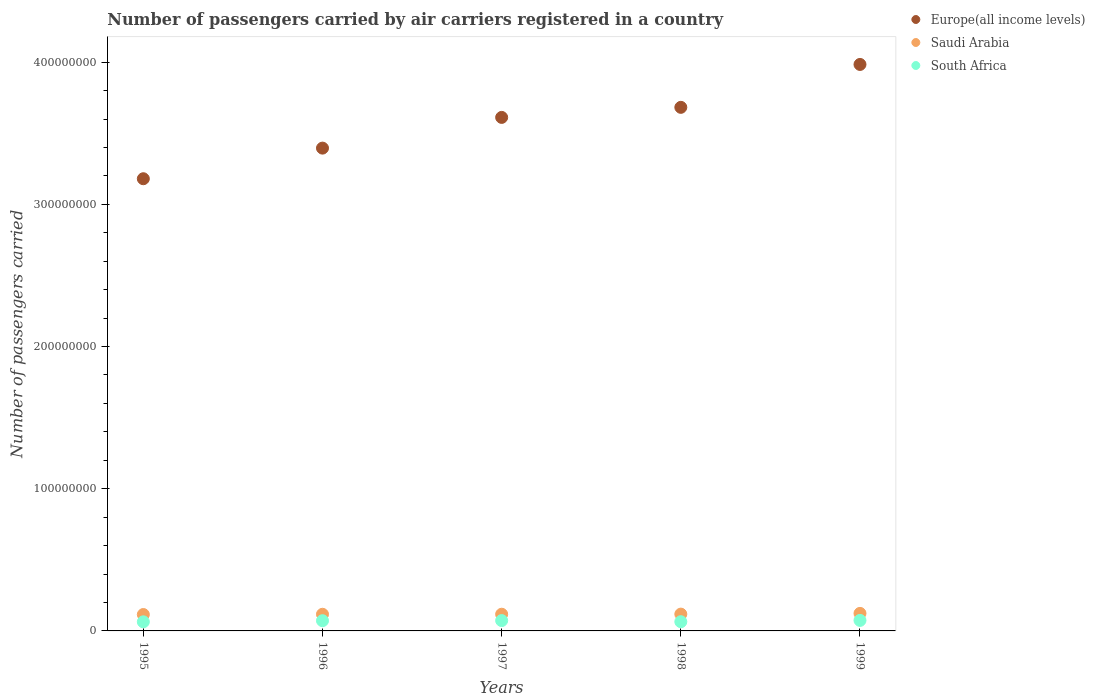What is the number of passengers carried by air carriers in Saudi Arabia in 1995?
Ensure brevity in your answer.  1.15e+07. Across all years, what is the maximum number of passengers carried by air carriers in Saudi Arabia?
Give a very brief answer. 1.23e+07. Across all years, what is the minimum number of passengers carried by air carriers in South Africa?
Your answer should be very brief. 6.40e+06. In which year was the number of passengers carried by air carriers in Saudi Arabia maximum?
Your response must be concise. 1999. What is the total number of passengers carried by air carriers in Saudi Arabia in the graph?
Provide a short and direct response. 5.91e+07. What is the difference between the number of passengers carried by air carriers in Saudi Arabia in 1995 and that in 1999?
Make the answer very short. -8.04e+05. What is the difference between the number of passengers carried by air carriers in Saudi Arabia in 1998 and the number of passengers carried by air carriers in South Africa in 1996?
Ensure brevity in your answer.  4.63e+06. What is the average number of passengers carried by air carriers in South Africa per year?
Keep it short and to the point. 6.95e+06. In the year 1998, what is the difference between the number of passengers carried by air carriers in Europe(all income levels) and number of passengers carried by air carriers in Saudi Arabia?
Provide a succinct answer. 3.56e+08. What is the ratio of the number of passengers carried by air carriers in Saudi Arabia in 1996 to that in 1999?
Provide a succinct answer. 0.95. Is the number of passengers carried by air carriers in South Africa in 1996 less than that in 1998?
Offer a terse response. No. Is the difference between the number of passengers carried by air carriers in Europe(all income levels) in 1995 and 1999 greater than the difference between the number of passengers carried by air carriers in Saudi Arabia in 1995 and 1999?
Offer a terse response. No. What is the difference between the highest and the second highest number of passengers carried by air carriers in South Africa?
Your answer should be compact. 1.30e+05. What is the difference between the highest and the lowest number of passengers carried by air carriers in Saudi Arabia?
Offer a terse response. 8.04e+05. In how many years, is the number of passengers carried by air carriers in Saudi Arabia greater than the average number of passengers carried by air carriers in Saudi Arabia taken over all years?
Provide a short and direct response. 1. Does the number of passengers carried by air carriers in Europe(all income levels) monotonically increase over the years?
Provide a succinct answer. Yes. Is the number of passengers carried by air carriers in Saudi Arabia strictly greater than the number of passengers carried by air carriers in Europe(all income levels) over the years?
Provide a succinct answer. No. Is the number of passengers carried by air carriers in Saudi Arabia strictly less than the number of passengers carried by air carriers in Europe(all income levels) over the years?
Keep it short and to the point. Yes. How many years are there in the graph?
Your response must be concise. 5. What is the difference between two consecutive major ticks on the Y-axis?
Your answer should be very brief. 1.00e+08. Are the values on the major ticks of Y-axis written in scientific E-notation?
Offer a very short reply. No. Does the graph contain any zero values?
Keep it short and to the point. No. Does the graph contain grids?
Provide a short and direct response. No. Where does the legend appear in the graph?
Your response must be concise. Top right. How many legend labels are there?
Your answer should be very brief. 3. How are the legend labels stacked?
Provide a short and direct response. Vertical. What is the title of the graph?
Your response must be concise. Number of passengers carried by air carriers registered in a country. Does "Greece" appear as one of the legend labels in the graph?
Your answer should be compact. No. What is the label or title of the Y-axis?
Offer a terse response. Number of passengers carried. What is the Number of passengers carried in Europe(all income levels) in 1995?
Keep it short and to the point. 3.18e+08. What is the Number of passengers carried in Saudi Arabia in 1995?
Offer a terse response. 1.15e+07. What is the Number of passengers carried of South Africa in 1995?
Give a very brief answer. 6.40e+06. What is the Number of passengers carried in Europe(all income levels) in 1996?
Provide a short and direct response. 3.40e+08. What is the Number of passengers carried of Saudi Arabia in 1996?
Provide a short and direct response. 1.17e+07. What is the Number of passengers carried in South Africa in 1996?
Your response must be concise. 7.18e+06. What is the Number of passengers carried of Europe(all income levels) in 1997?
Offer a very short reply. 3.61e+08. What is the Number of passengers carried of Saudi Arabia in 1997?
Give a very brief answer. 1.17e+07. What is the Number of passengers carried in South Africa in 1997?
Offer a terse response. 7.27e+06. What is the Number of passengers carried in Europe(all income levels) in 1998?
Your response must be concise. 3.68e+08. What is the Number of passengers carried of Saudi Arabia in 1998?
Offer a terse response. 1.18e+07. What is the Number of passengers carried in South Africa in 1998?
Provide a succinct answer. 6.48e+06. What is the Number of passengers carried in Europe(all income levels) in 1999?
Your answer should be compact. 3.98e+08. What is the Number of passengers carried of Saudi Arabia in 1999?
Your answer should be very brief. 1.23e+07. What is the Number of passengers carried in South Africa in 1999?
Offer a very short reply. 7.40e+06. Across all years, what is the maximum Number of passengers carried of Europe(all income levels)?
Ensure brevity in your answer.  3.98e+08. Across all years, what is the maximum Number of passengers carried of Saudi Arabia?
Make the answer very short. 1.23e+07. Across all years, what is the maximum Number of passengers carried of South Africa?
Your answer should be very brief. 7.40e+06. Across all years, what is the minimum Number of passengers carried of Europe(all income levels)?
Make the answer very short. 3.18e+08. Across all years, what is the minimum Number of passengers carried in Saudi Arabia?
Your response must be concise. 1.15e+07. Across all years, what is the minimum Number of passengers carried of South Africa?
Keep it short and to the point. 6.40e+06. What is the total Number of passengers carried in Europe(all income levels) in the graph?
Your answer should be very brief. 1.79e+09. What is the total Number of passengers carried in Saudi Arabia in the graph?
Make the answer very short. 5.91e+07. What is the total Number of passengers carried in South Africa in the graph?
Your answer should be very brief. 3.47e+07. What is the difference between the Number of passengers carried of Europe(all income levels) in 1995 and that in 1996?
Offer a terse response. -2.15e+07. What is the difference between the Number of passengers carried in Saudi Arabia in 1995 and that in 1996?
Ensure brevity in your answer.  -1.82e+05. What is the difference between the Number of passengers carried of South Africa in 1995 and that in 1996?
Keep it short and to the point. -7.88e+05. What is the difference between the Number of passengers carried in Europe(all income levels) in 1995 and that in 1997?
Give a very brief answer. -4.31e+07. What is the difference between the Number of passengers carried of Saudi Arabia in 1995 and that in 1997?
Provide a succinct answer. -2.14e+05. What is the difference between the Number of passengers carried in South Africa in 1995 and that in 1997?
Provide a succinct answer. -8.79e+05. What is the difference between the Number of passengers carried in Europe(all income levels) in 1995 and that in 1998?
Ensure brevity in your answer.  -5.02e+07. What is the difference between the Number of passengers carried in Saudi Arabia in 1995 and that in 1998?
Keep it short and to the point. -2.92e+05. What is the difference between the Number of passengers carried of South Africa in 1995 and that in 1998?
Your answer should be very brief. -8.40e+04. What is the difference between the Number of passengers carried in Europe(all income levels) in 1995 and that in 1999?
Keep it short and to the point. -8.04e+07. What is the difference between the Number of passengers carried of Saudi Arabia in 1995 and that in 1999?
Provide a succinct answer. -8.04e+05. What is the difference between the Number of passengers carried in South Africa in 1995 and that in 1999?
Provide a succinct answer. -1.01e+06. What is the difference between the Number of passengers carried of Europe(all income levels) in 1996 and that in 1997?
Your answer should be compact. -2.16e+07. What is the difference between the Number of passengers carried in Saudi Arabia in 1996 and that in 1997?
Provide a succinct answer. -3.19e+04. What is the difference between the Number of passengers carried of South Africa in 1996 and that in 1997?
Make the answer very short. -9.11e+04. What is the difference between the Number of passengers carried in Europe(all income levels) in 1996 and that in 1998?
Offer a very short reply. -2.87e+07. What is the difference between the Number of passengers carried in Saudi Arabia in 1996 and that in 1998?
Ensure brevity in your answer.  -1.10e+05. What is the difference between the Number of passengers carried of South Africa in 1996 and that in 1998?
Offer a terse response. 7.04e+05. What is the difference between the Number of passengers carried in Europe(all income levels) in 1996 and that in 1999?
Your answer should be very brief. -5.88e+07. What is the difference between the Number of passengers carried in Saudi Arabia in 1996 and that in 1999?
Make the answer very short. -6.22e+05. What is the difference between the Number of passengers carried in South Africa in 1996 and that in 1999?
Offer a very short reply. -2.21e+05. What is the difference between the Number of passengers carried of Europe(all income levels) in 1997 and that in 1998?
Keep it short and to the point. -7.08e+06. What is the difference between the Number of passengers carried of Saudi Arabia in 1997 and that in 1998?
Provide a short and direct response. -7.80e+04. What is the difference between the Number of passengers carried of South Africa in 1997 and that in 1998?
Your answer should be very brief. 7.95e+05. What is the difference between the Number of passengers carried of Europe(all income levels) in 1997 and that in 1999?
Your response must be concise. -3.72e+07. What is the difference between the Number of passengers carried in Saudi Arabia in 1997 and that in 1999?
Provide a succinct answer. -5.90e+05. What is the difference between the Number of passengers carried in South Africa in 1997 and that in 1999?
Your answer should be very brief. -1.30e+05. What is the difference between the Number of passengers carried of Europe(all income levels) in 1998 and that in 1999?
Offer a terse response. -3.02e+07. What is the difference between the Number of passengers carried of Saudi Arabia in 1998 and that in 1999?
Ensure brevity in your answer.  -5.12e+05. What is the difference between the Number of passengers carried in South Africa in 1998 and that in 1999?
Make the answer very short. -9.24e+05. What is the difference between the Number of passengers carried of Europe(all income levels) in 1995 and the Number of passengers carried of Saudi Arabia in 1996?
Ensure brevity in your answer.  3.06e+08. What is the difference between the Number of passengers carried in Europe(all income levels) in 1995 and the Number of passengers carried in South Africa in 1996?
Your response must be concise. 3.11e+08. What is the difference between the Number of passengers carried of Saudi Arabia in 1995 and the Number of passengers carried of South Africa in 1996?
Make the answer very short. 4.34e+06. What is the difference between the Number of passengers carried of Europe(all income levels) in 1995 and the Number of passengers carried of Saudi Arabia in 1997?
Provide a succinct answer. 3.06e+08. What is the difference between the Number of passengers carried of Europe(all income levels) in 1995 and the Number of passengers carried of South Africa in 1997?
Provide a short and direct response. 3.11e+08. What is the difference between the Number of passengers carried of Saudi Arabia in 1995 and the Number of passengers carried of South Africa in 1997?
Your answer should be compact. 4.25e+06. What is the difference between the Number of passengers carried in Europe(all income levels) in 1995 and the Number of passengers carried in Saudi Arabia in 1998?
Give a very brief answer. 3.06e+08. What is the difference between the Number of passengers carried in Europe(all income levels) in 1995 and the Number of passengers carried in South Africa in 1998?
Provide a succinct answer. 3.12e+08. What is the difference between the Number of passengers carried in Saudi Arabia in 1995 and the Number of passengers carried in South Africa in 1998?
Your answer should be compact. 5.04e+06. What is the difference between the Number of passengers carried in Europe(all income levels) in 1995 and the Number of passengers carried in Saudi Arabia in 1999?
Give a very brief answer. 3.06e+08. What is the difference between the Number of passengers carried in Europe(all income levels) in 1995 and the Number of passengers carried in South Africa in 1999?
Make the answer very short. 3.11e+08. What is the difference between the Number of passengers carried in Saudi Arabia in 1995 and the Number of passengers carried in South Africa in 1999?
Give a very brief answer. 4.12e+06. What is the difference between the Number of passengers carried of Europe(all income levels) in 1996 and the Number of passengers carried of Saudi Arabia in 1997?
Your answer should be compact. 3.28e+08. What is the difference between the Number of passengers carried of Europe(all income levels) in 1996 and the Number of passengers carried of South Africa in 1997?
Your answer should be very brief. 3.32e+08. What is the difference between the Number of passengers carried of Saudi Arabia in 1996 and the Number of passengers carried of South Africa in 1997?
Give a very brief answer. 4.43e+06. What is the difference between the Number of passengers carried of Europe(all income levels) in 1996 and the Number of passengers carried of Saudi Arabia in 1998?
Your response must be concise. 3.28e+08. What is the difference between the Number of passengers carried of Europe(all income levels) in 1996 and the Number of passengers carried of South Africa in 1998?
Ensure brevity in your answer.  3.33e+08. What is the difference between the Number of passengers carried in Saudi Arabia in 1996 and the Number of passengers carried in South Africa in 1998?
Give a very brief answer. 5.23e+06. What is the difference between the Number of passengers carried in Europe(all income levels) in 1996 and the Number of passengers carried in Saudi Arabia in 1999?
Offer a terse response. 3.27e+08. What is the difference between the Number of passengers carried in Europe(all income levels) in 1996 and the Number of passengers carried in South Africa in 1999?
Your answer should be compact. 3.32e+08. What is the difference between the Number of passengers carried in Saudi Arabia in 1996 and the Number of passengers carried in South Africa in 1999?
Offer a terse response. 4.30e+06. What is the difference between the Number of passengers carried of Europe(all income levels) in 1997 and the Number of passengers carried of Saudi Arabia in 1998?
Ensure brevity in your answer.  3.49e+08. What is the difference between the Number of passengers carried of Europe(all income levels) in 1997 and the Number of passengers carried of South Africa in 1998?
Your answer should be compact. 3.55e+08. What is the difference between the Number of passengers carried in Saudi Arabia in 1997 and the Number of passengers carried in South Africa in 1998?
Provide a short and direct response. 5.26e+06. What is the difference between the Number of passengers carried in Europe(all income levels) in 1997 and the Number of passengers carried in Saudi Arabia in 1999?
Your response must be concise. 3.49e+08. What is the difference between the Number of passengers carried of Europe(all income levels) in 1997 and the Number of passengers carried of South Africa in 1999?
Offer a terse response. 3.54e+08. What is the difference between the Number of passengers carried of Saudi Arabia in 1997 and the Number of passengers carried of South Africa in 1999?
Offer a terse response. 4.33e+06. What is the difference between the Number of passengers carried in Europe(all income levels) in 1998 and the Number of passengers carried in Saudi Arabia in 1999?
Your answer should be very brief. 3.56e+08. What is the difference between the Number of passengers carried of Europe(all income levels) in 1998 and the Number of passengers carried of South Africa in 1999?
Keep it short and to the point. 3.61e+08. What is the difference between the Number of passengers carried in Saudi Arabia in 1998 and the Number of passengers carried in South Africa in 1999?
Offer a terse response. 4.41e+06. What is the average Number of passengers carried of Europe(all income levels) per year?
Provide a short and direct response. 3.57e+08. What is the average Number of passengers carried of Saudi Arabia per year?
Make the answer very short. 1.18e+07. What is the average Number of passengers carried in South Africa per year?
Ensure brevity in your answer.  6.95e+06. In the year 1995, what is the difference between the Number of passengers carried in Europe(all income levels) and Number of passengers carried in Saudi Arabia?
Provide a succinct answer. 3.06e+08. In the year 1995, what is the difference between the Number of passengers carried of Europe(all income levels) and Number of passengers carried of South Africa?
Offer a terse response. 3.12e+08. In the year 1995, what is the difference between the Number of passengers carried in Saudi Arabia and Number of passengers carried in South Africa?
Provide a succinct answer. 5.13e+06. In the year 1996, what is the difference between the Number of passengers carried in Europe(all income levels) and Number of passengers carried in Saudi Arabia?
Provide a short and direct response. 3.28e+08. In the year 1996, what is the difference between the Number of passengers carried of Europe(all income levels) and Number of passengers carried of South Africa?
Offer a very short reply. 3.32e+08. In the year 1996, what is the difference between the Number of passengers carried of Saudi Arabia and Number of passengers carried of South Africa?
Offer a very short reply. 4.52e+06. In the year 1997, what is the difference between the Number of passengers carried in Europe(all income levels) and Number of passengers carried in Saudi Arabia?
Your answer should be very brief. 3.49e+08. In the year 1997, what is the difference between the Number of passengers carried of Europe(all income levels) and Number of passengers carried of South Africa?
Ensure brevity in your answer.  3.54e+08. In the year 1997, what is the difference between the Number of passengers carried of Saudi Arabia and Number of passengers carried of South Africa?
Provide a succinct answer. 4.46e+06. In the year 1998, what is the difference between the Number of passengers carried of Europe(all income levels) and Number of passengers carried of Saudi Arabia?
Give a very brief answer. 3.56e+08. In the year 1998, what is the difference between the Number of passengers carried of Europe(all income levels) and Number of passengers carried of South Africa?
Your response must be concise. 3.62e+08. In the year 1998, what is the difference between the Number of passengers carried of Saudi Arabia and Number of passengers carried of South Africa?
Your answer should be compact. 5.34e+06. In the year 1999, what is the difference between the Number of passengers carried in Europe(all income levels) and Number of passengers carried in Saudi Arabia?
Provide a short and direct response. 3.86e+08. In the year 1999, what is the difference between the Number of passengers carried of Europe(all income levels) and Number of passengers carried of South Africa?
Offer a very short reply. 3.91e+08. In the year 1999, what is the difference between the Number of passengers carried in Saudi Arabia and Number of passengers carried in South Africa?
Make the answer very short. 4.92e+06. What is the ratio of the Number of passengers carried of Europe(all income levels) in 1995 to that in 1996?
Offer a terse response. 0.94. What is the ratio of the Number of passengers carried in Saudi Arabia in 1995 to that in 1996?
Provide a succinct answer. 0.98. What is the ratio of the Number of passengers carried of South Africa in 1995 to that in 1996?
Your answer should be compact. 0.89. What is the ratio of the Number of passengers carried in Europe(all income levels) in 1995 to that in 1997?
Offer a terse response. 0.88. What is the ratio of the Number of passengers carried in Saudi Arabia in 1995 to that in 1997?
Provide a short and direct response. 0.98. What is the ratio of the Number of passengers carried of South Africa in 1995 to that in 1997?
Your response must be concise. 0.88. What is the ratio of the Number of passengers carried in Europe(all income levels) in 1995 to that in 1998?
Provide a short and direct response. 0.86. What is the ratio of the Number of passengers carried of Saudi Arabia in 1995 to that in 1998?
Offer a terse response. 0.98. What is the ratio of the Number of passengers carried in South Africa in 1995 to that in 1998?
Offer a very short reply. 0.99. What is the ratio of the Number of passengers carried in Europe(all income levels) in 1995 to that in 1999?
Offer a very short reply. 0.8. What is the ratio of the Number of passengers carried in Saudi Arabia in 1995 to that in 1999?
Provide a short and direct response. 0.93. What is the ratio of the Number of passengers carried in South Africa in 1995 to that in 1999?
Make the answer very short. 0.86. What is the ratio of the Number of passengers carried in Europe(all income levels) in 1996 to that in 1997?
Provide a short and direct response. 0.94. What is the ratio of the Number of passengers carried of Saudi Arabia in 1996 to that in 1997?
Your response must be concise. 1. What is the ratio of the Number of passengers carried in South Africa in 1996 to that in 1997?
Make the answer very short. 0.99. What is the ratio of the Number of passengers carried in Europe(all income levels) in 1996 to that in 1998?
Offer a terse response. 0.92. What is the ratio of the Number of passengers carried of Saudi Arabia in 1996 to that in 1998?
Give a very brief answer. 0.99. What is the ratio of the Number of passengers carried in South Africa in 1996 to that in 1998?
Offer a very short reply. 1.11. What is the ratio of the Number of passengers carried in Europe(all income levels) in 1996 to that in 1999?
Provide a succinct answer. 0.85. What is the ratio of the Number of passengers carried of Saudi Arabia in 1996 to that in 1999?
Give a very brief answer. 0.95. What is the ratio of the Number of passengers carried in South Africa in 1996 to that in 1999?
Offer a terse response. 0.97. What is the ratio of the Number of passengers carried of Europe(all income levels) in 1997 to that in 1998?
Provide a succinct answer. 0.98. What is the ratio of the Number of passengers carried of South Africa in 1997 to that in 1998?
Ensure brevity in your answer.  1.12. What is the ratio of the Number of passengers carried in Europe(all income levels) in 1997 to that in 1999?
Offer a very short reply. 0.91. What is the ratio of the Number of passengers carried of Saudi Arabia in 1997 to that in 1999?
Offer a terse response. 0.95. What is the ratio of the Number of passengers carried of South Africa in 1997 to that in 1999?
Your answer should be compact. 0.98. What is the ratio of the Number of passengers carried of Europe(all income levels) in 1998 to that in 1999?
Your answer should be very brief. 0.92. What is the ratio of the Number of passengers carried in Saudi Arabia in 1998 to that in 1999?
Offer a terse response. 0.96. What is the ratio of the Number of passengers carried in South Africa in 1998 to that in 1999?
Give a very brief answer. 0.88. What is the difference between the highest and the second highest Number of passengers carried in Europe(all income levels)?
Your answer should be very brief. 3.02e+07. What is the difference between the highest and the second highest Number of passengers carried in Saudi Arabia?
Your answer should be very brief. 5.12e+05. What is the difference between the highest and the second highest Number of passengers carried of South Africa?
Your answer should be very brief. 1.30e+05. What is the difference between the highest and the lowest Number of passengers carried in Europe(all income levels)?
Offer a very short reply. 8.04e+07. What is the difference between the highest and the lowest Number of passengers carried of Saudi Arabia?
Give a very brief answer. 8.04e+05. What is the difference between the highest and the lowest Number of passengers carried in South Africa?
Give a very brief answer. 1.01e+06. 